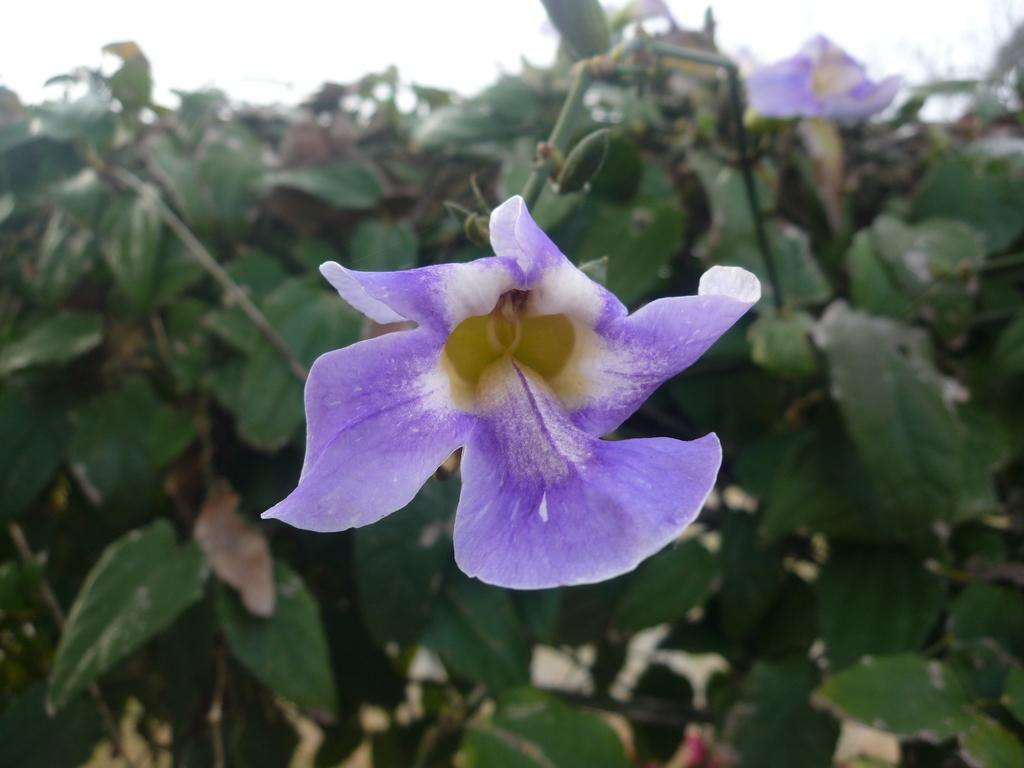What is the main subject of the image? There is a flower in the image. Can you describe the colors of the flower? The flower has violet and white colors. What can be seen behind the flower? There are green leaves behind the flower. What type of ghost can be seen interacting with the flower in the image? There is no ghost present in the image; it only features a flower and green leaves. Can you tell me how many cans are visible in the image? There are no cans present in the image; it only features a flower, green leaves, and their respective colors. 